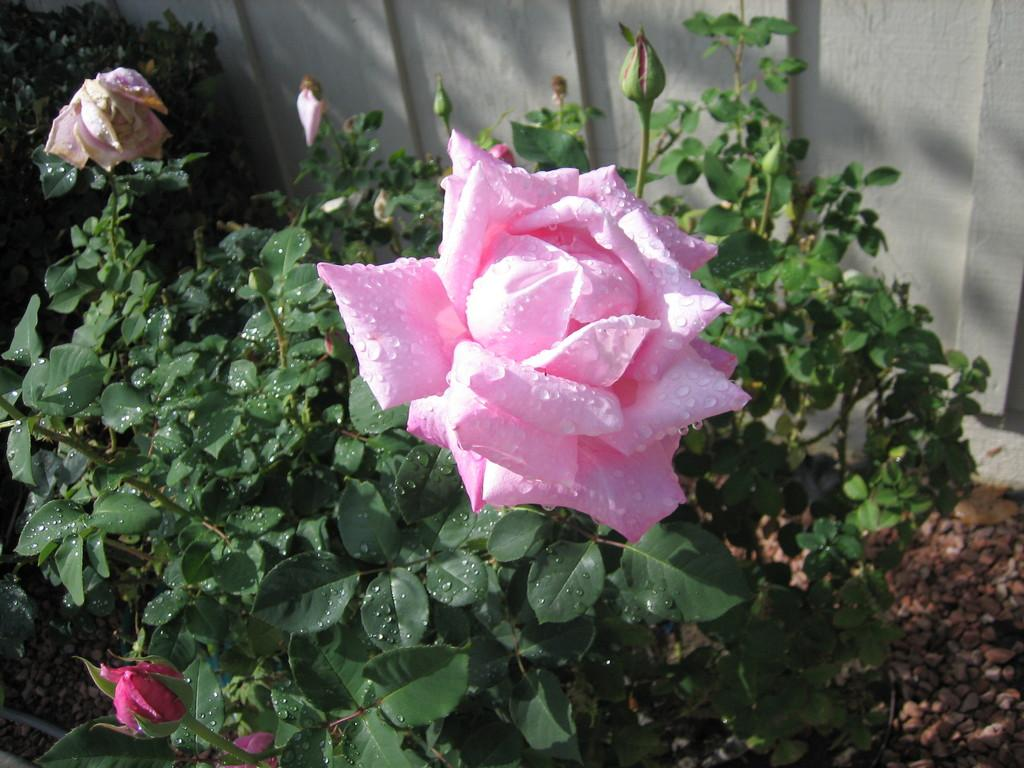What type of flower is in the image? There is a rose flower in the image. What stage of growth are the other flowers on the plant in the image? There are buds on a plant in the image. What can be seen in the background of the image? There is a wall in the background of the image. What type of carriage is being used to transport the rose flower in the image? There is no carriage present in the image; the rose flower is not being transported. 